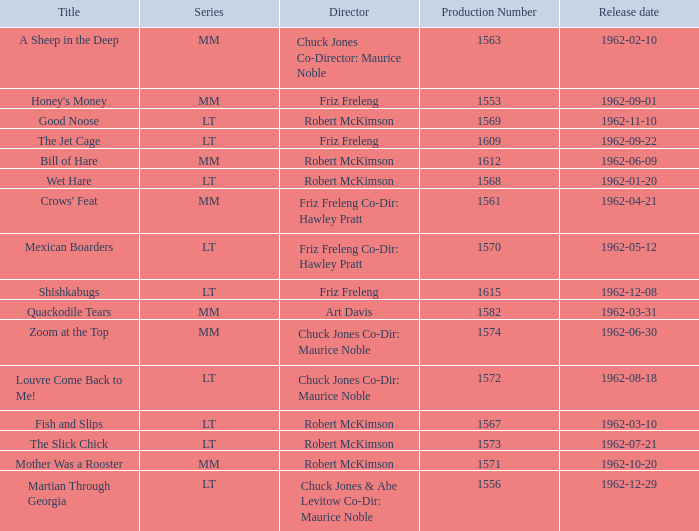What is the title of the film with production number 1553, directed by Friz Freleng? Honey's Money. 